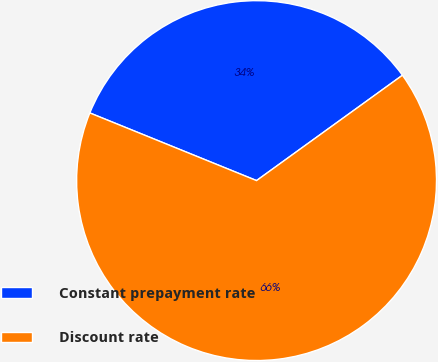<chart> <loc_0><loc_0><loc_500><loc_500><pie_chart><fcel>Constant prepayment rate<fcel>Discount rate<nl><fcel>33.91%<fcel>66.09%<nl></chart> 